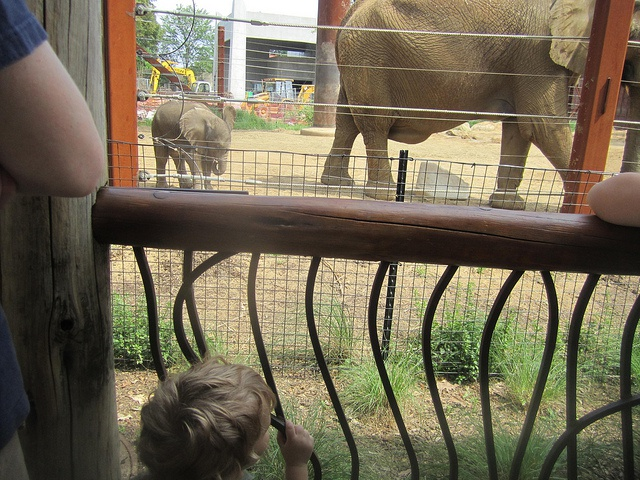Describe the objects in this image and their specific colors. I can see elephant in black, gray, and tan tones, people in gray, black, and darkgray tones, people in black and gray tones, elephant in black, gray, and tan tones, and people in black, brown, and gray tones in this image. 